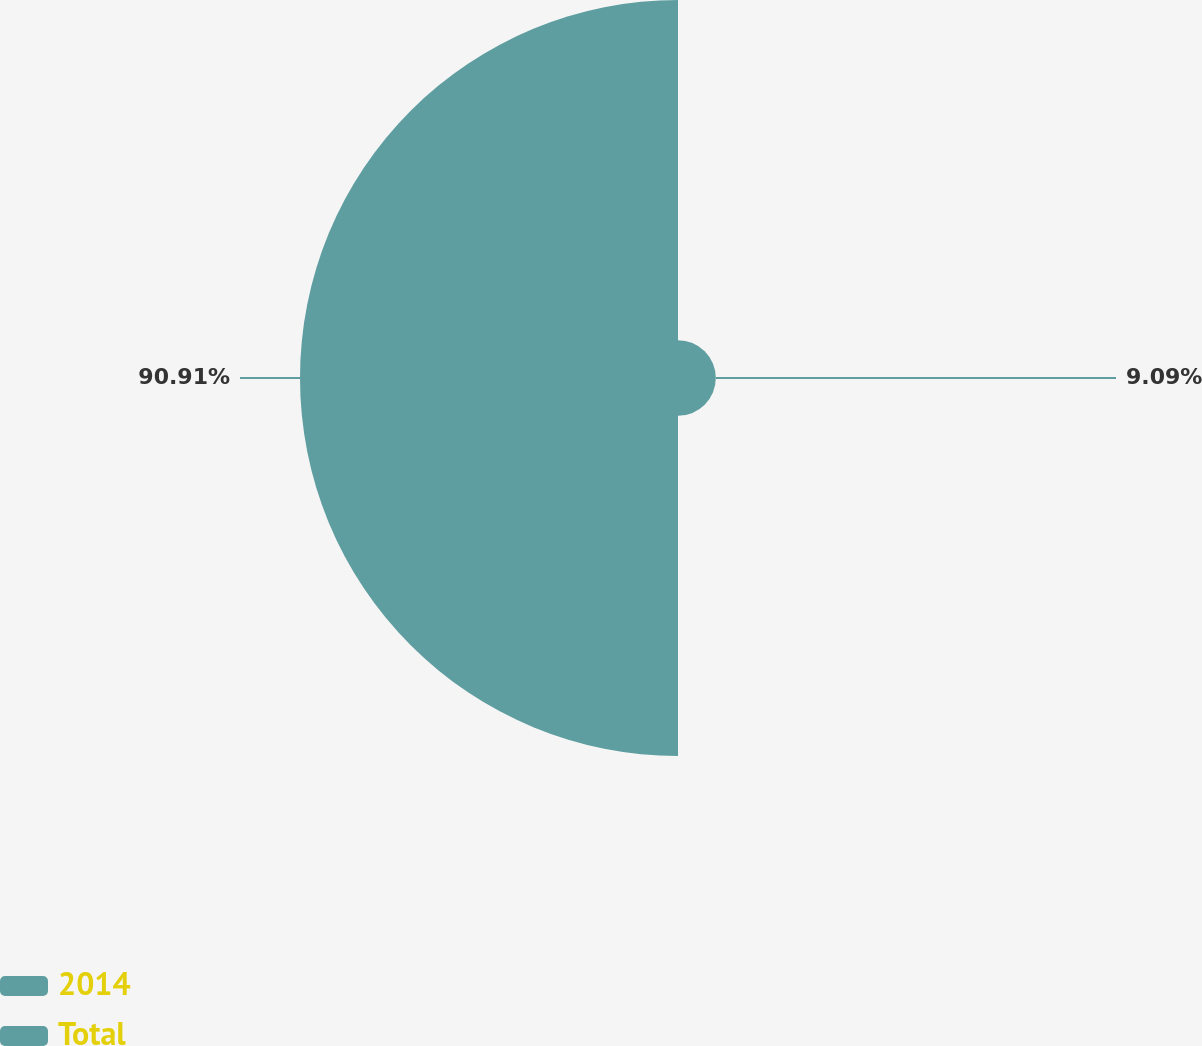Convert chart to OTSL. <chart><loc_0><loc_0><loc_500><loc_500><pie_chart><fcel>2014<fcel>Total<nl><fcel>9.09%<fcel>90.91%<nl></chart> 